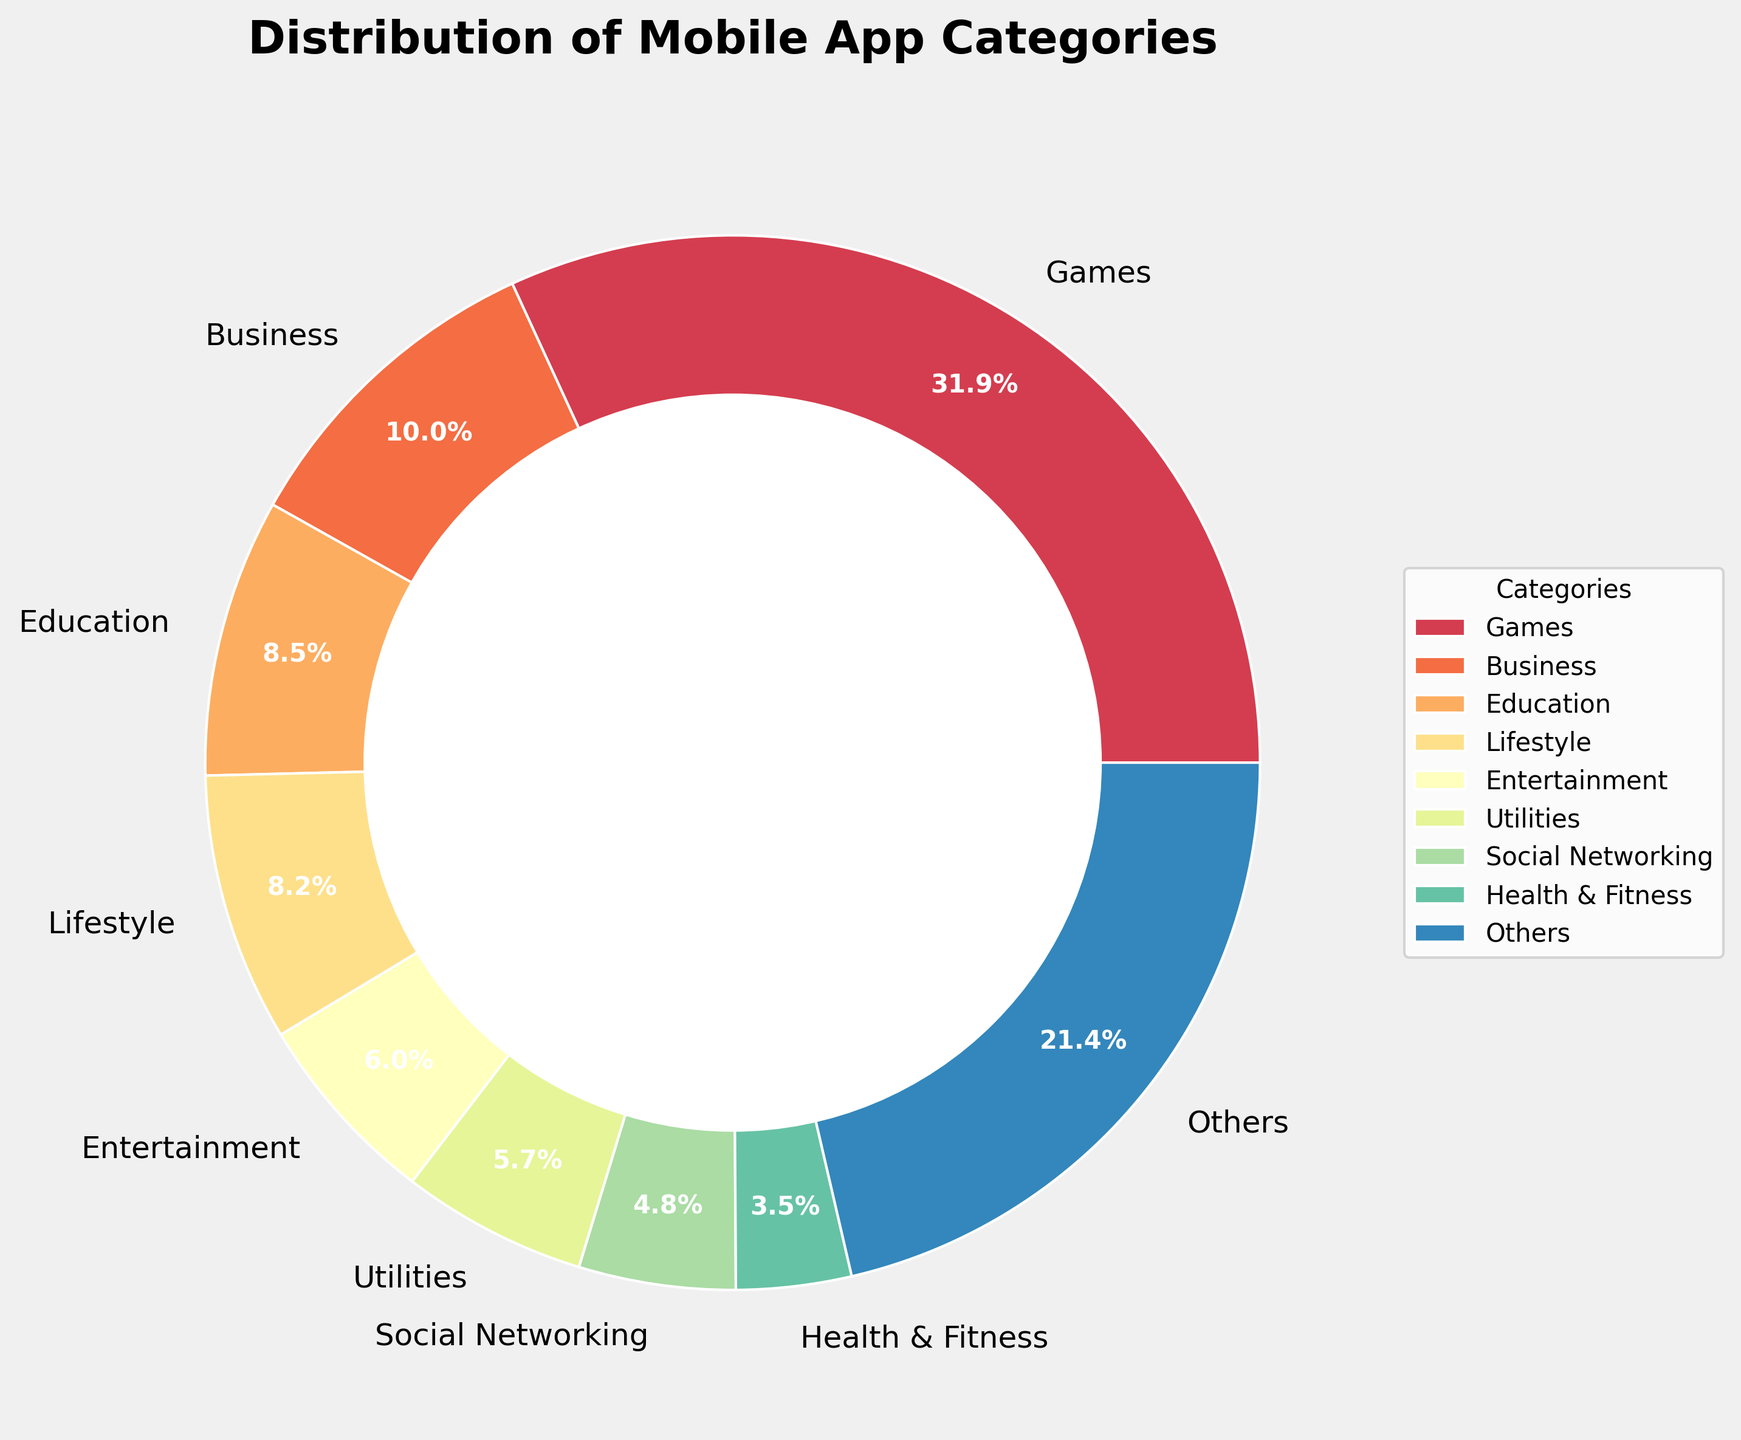What's the largest category in terms of percentage, and what percentage does it hold? By looking at the pie chart, identify the segment with the largest area. The label on that segment will have the category name and its corresponding percentage.
Answer: Games, 32.5% How much larger is the Games category compared to the Business category? Determine the percentage of both the Games and Business categories from the chart. Then, subtract the Business percentage from the Games percentage: 32.5 - 10.2 = 22.3
Answer: 22.3% What's the combined percentage of the top 3 categories? Identify the top 3 categories based on their percentages: Games, Business, and Education. Sum their percentages: 32.5 + 10.2 + 8.7 = 51.4
Answer: 51.4% Is the percentage of Health & Fitness apps greater than or less than the percentage of Music apps? Compare the segments labeled Health & Fitness and Music. Health & Fitness has 3.6%, while Music has 1.4%. 3.6 is greater than 1.4.
Answer: Greater than What's the sum of the percentages for the Entertainment, Utilities, and Social Networking categories? Identify and sum the percentages from the pie chart for these three categories: Entertainment - 6.1%, Utilities - 5.8%, and Social Networking - 4.9%. So, 6.1 + 5.8 + 4.9 = 16.8
Answer: 16.8% Which category has the smallest percentage, and what is it? Find the smallest segment on the pie chart and read its label for the category and percentage.
Answer: Navigation, 0.4% What color is used to represent the Lifestyle category in the pie chart? Locate the segment labeled 'Lifestyle' and describe its color from the chart.
Answer: Depending on the palette used, it might be a specific shade (the example uses "Spectral" so it would be a distinct color in that gradient spectrum) Are the combined percentages of Education and Health & Fitness greater than that of Entertainment and Productivity? Calculate the sum for both pairs: Education (8.7) + Health & Fitness (3.6) = 12.3, and Entertainment (6.1) + Productivity (3.4) = 9.5. Compare the sums: 12.3 > 9.5 so Education and Health & Fitness are greater.
Answer: Yes How does the percentage of Food & Drink compare to the percentage of Finance category? Look at each segment’s label to find the Food & Drink and Finance categories. Food & Drink is 2.5%, and Finance is 3.2%. Therefore, Food & Drink is less than Finance.
Answer: Less than What is the total percentage of all categories not in the top 8? Identify the "Others" segment on the pie chart, which represents the combined percentage of all categories outside the top 8. The value is directly given as one combined percentage for "Others".
Answer: Sum not directly presented, but can check the 'Others' section, which is the sum of the remaining categories 